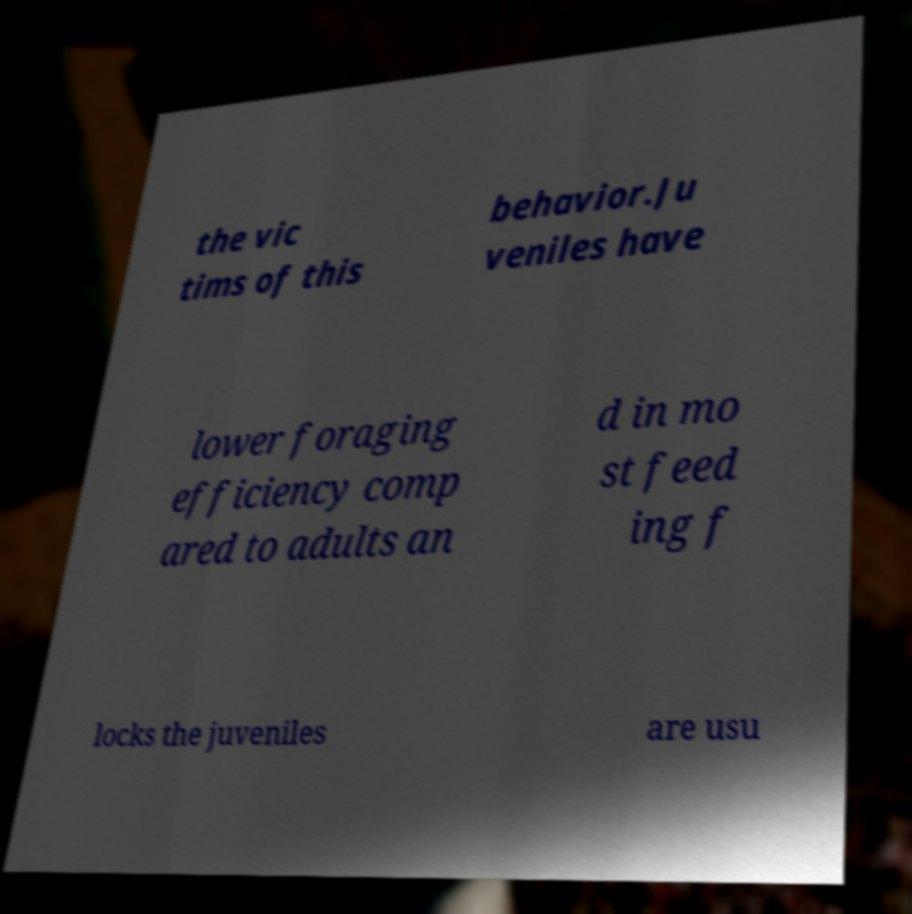Please read and relay the text visible in this image. What does it say? the vic tims of this behavior.Ju veniles have lower foraging efficiency comp ared to adults an d in mo st feed ing f locks the juveniles are usu 